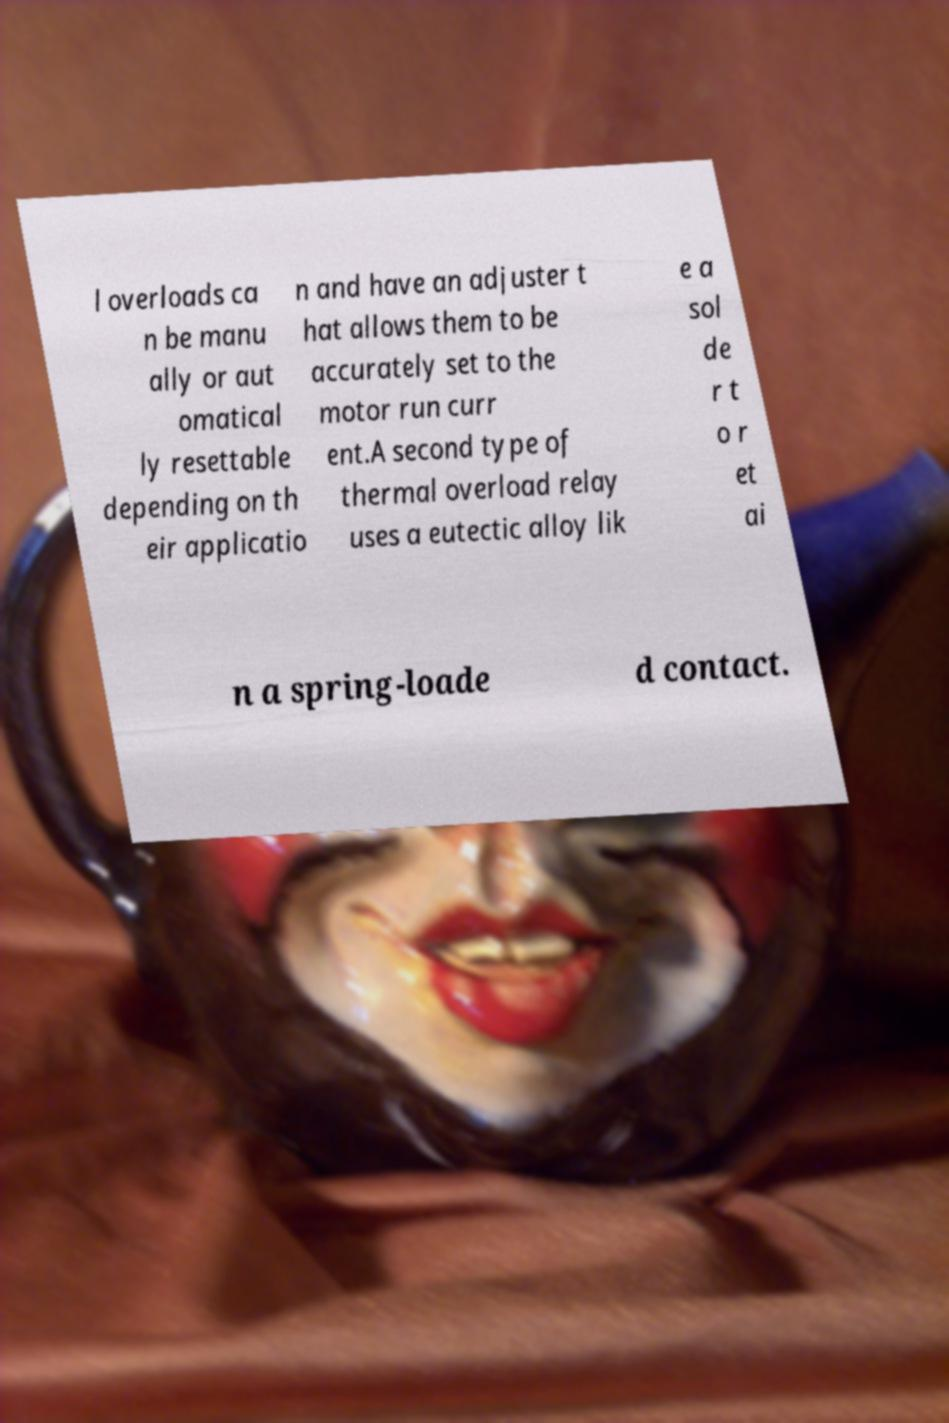For documentation purposes, I need the text within this image transcribed. Could you provide that? l overloads ca n be manu ally or aut omatical ly resettable depending on th eir applicatio n and have an adjuster t hat allows them to be accurately set to the motor run curr ent.A second type of thermal overload relay uses a eutectic alloy lik e a sol de r t o r et ai n a spring-loade d contact. 